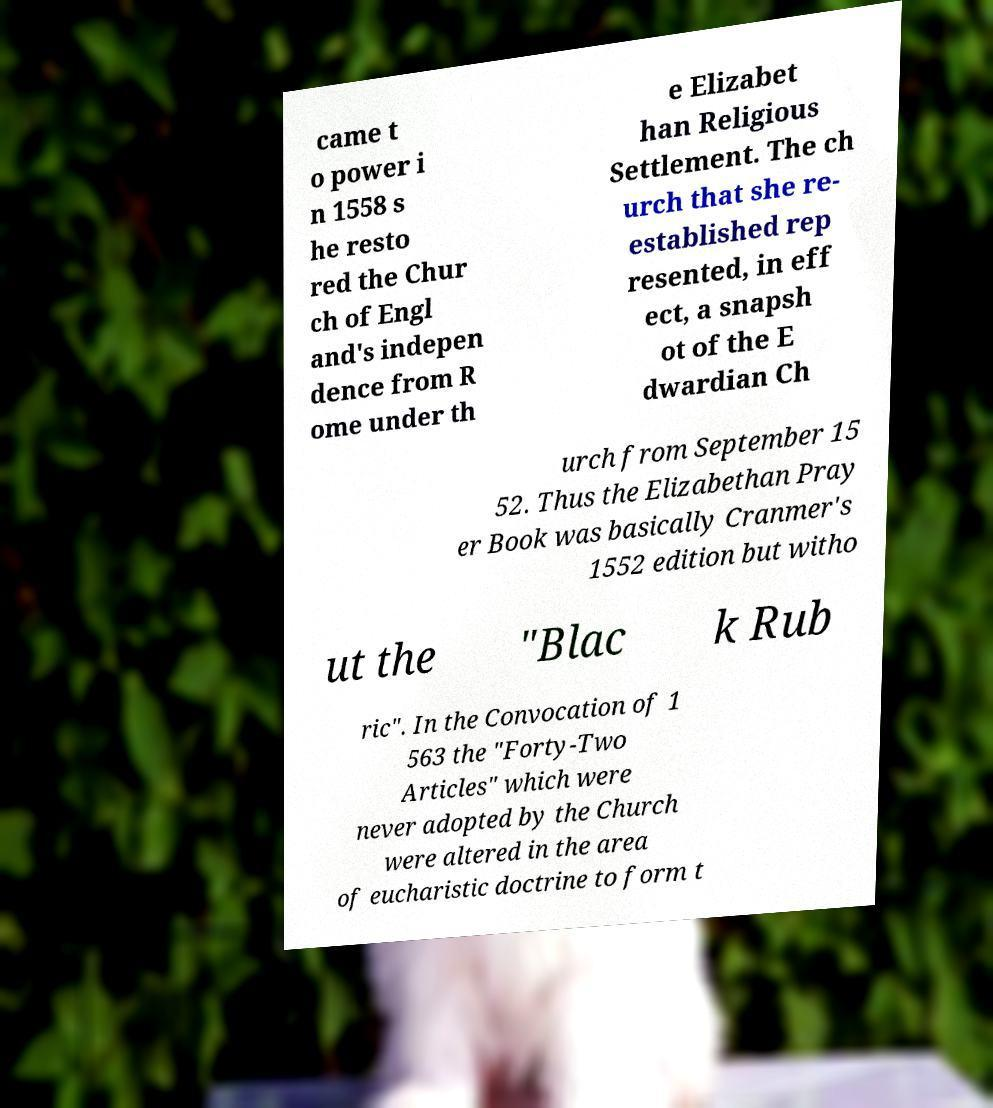Could you extract and type out the text from this image? came t o power i n 1558 s he resto red the Chur ch of Engl and's indepen dence from R ome under th e Elizabet han Religious Settlement. The ch urch that she re- established rep resented, in eff ect, a snapsh ot of the E dwardian Ch urch from September 15 52. Thus the Elizabethan Pray er Book was basically Cranmer's 1552 edition but witho ut the "Blac k Rub ric". In the Convocation of 1 563 the "Forty-Two Articles" which were never adopted by the Church were altered in the area of eucharistic doctrine to form t 